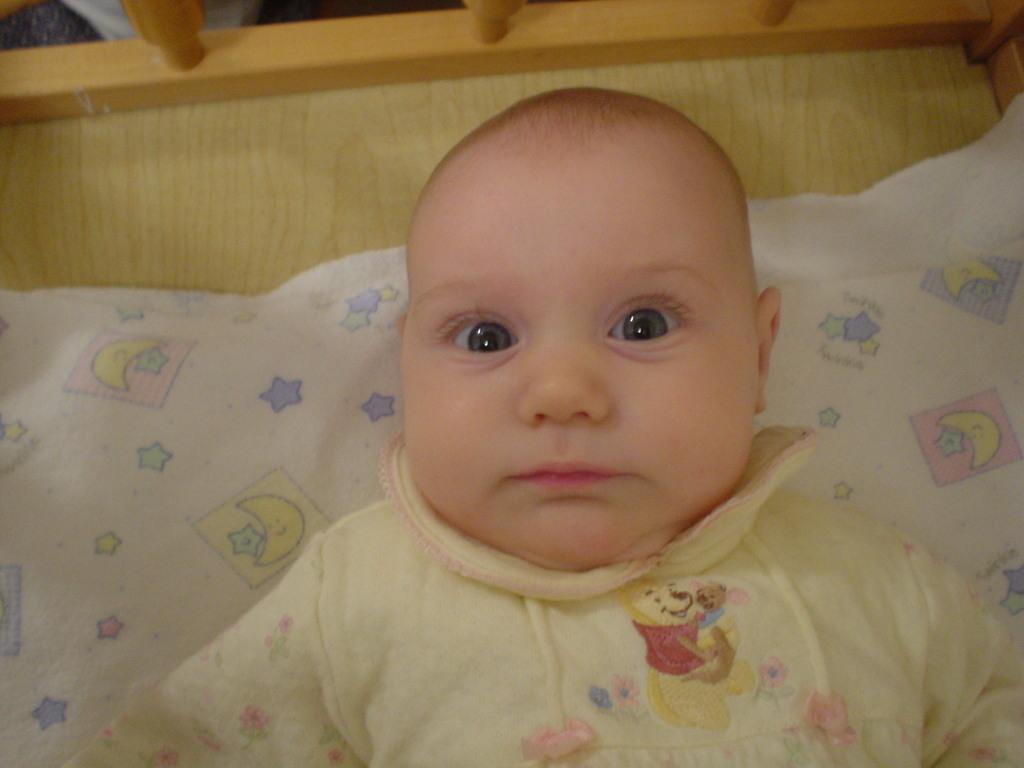Could you give a brief overview of what you see in this image? There is a baby wearing yellow dress is sleeping on a white color object. 